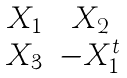Convert formula to latex. <formula><loc_0><loc_0><loc_500><loc_500>\begin{matrix} X _ { 1 } & X _ { 2 } \\ X _ { 3 } & - X _ { 1 } ^ { t } \end{matrix}</formula> 